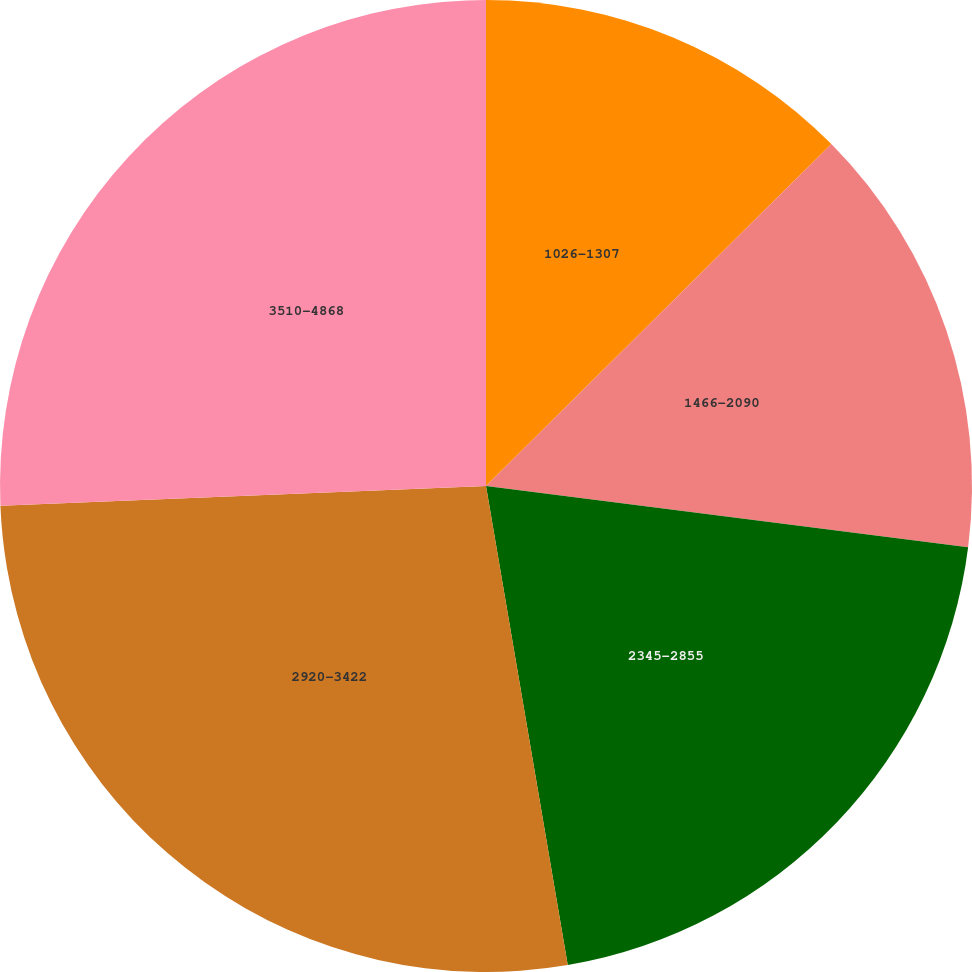Convert chart to OTSL. <chart><loc_0><loc_0><loc_500><loc_500><pie_chart><fcel>1026-1307<fcel>1466-2090<fcel>2345-2855<fcel>2920-3422<fcel>3510-4868<nl><fcel>12.58%<fcel>14.43%<fcel>20.3%<fcel>27.04%<fcel>25.65%<nl></chart> 